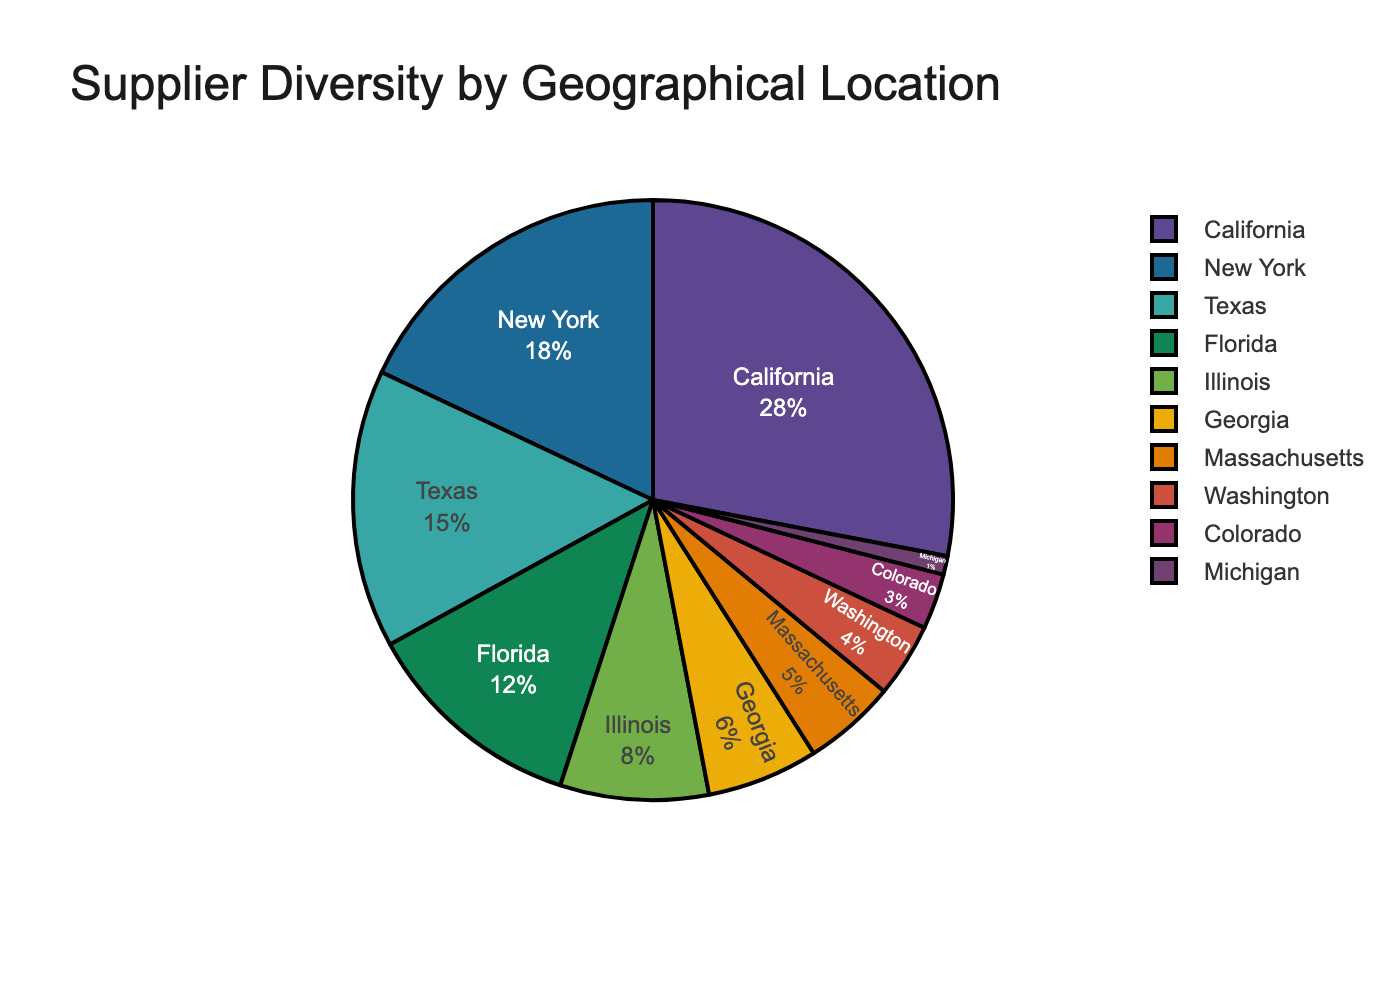Which region has the largest percentage of suppliers? The pie chart shows California has the largest section.
Answer: California Which region has the smallest percentage of suppliers? The pie chart indicates Michigan has the smallest section.
Answer: Michigan What is the combined percentage of suppliers from California and New York? California has 28% and New York has 18%. Adding them together, 28% + 18% = 46%.
Answer: 46% How many percentage points more suppliers are in Texas than in Florida? Texas has 15% and Florida has 12%. Subtracting these, 15% - 12% = 3%.
Answer: 3% What is the average percentage of suppliers from Illinois, Georgia, Massachusetts, Washington, Colorado, and Michigan? The percentages are 8%, 6%, 5%, 4%, 3%, and 1%. Summing them, 8% + 6% + 5% + 4% + 3% + 1% = 27%. There are 6 regions, so averaging, 27% / 6 = 4.5%.
Answer: 4.5% How do the percentages of suppliers from California and Texas compare? California has 28% and Texas has 15%. California's percentage is greater.
Answer: California's is greater Which color represents Florida on the pie chart? By examining the pie chart, the section for Florida can be visually identified by its color.
Answer: (Visual Attribute: Identify the color segment) What is the difference in supplier percentages between the West Coast regions (California and Washington) and the East Coast regions (New York, Massachusetts, and Florida)? West Coast: California (28%) + Washington (4%) = 32%. East Coast: New York (18%) + Massachusetts (5%) + Florida (12%) = 35%. The difference is 35% - 32% = 3%.
Answer: 3% Order the regions by supplier percentage in ascending order. From smallest to largest: Michigan (1%), Colorado (3%), Washington (4%), Massachusetts (5%), Georgia (6%), Illinois (8%), Florida (12%), Texas (15%), New York (18%), California (28%).
Answer: Michigan, Colorado, Washington, Massachusetts, Georgia, Illinois, Florida, Texas, New York, California What is the percentage difference between New York and Illinois suppliers? New York has 18% and Illinois has 8%. Subtracting these, 18% - 8% = 10%.
Answer: 10% 